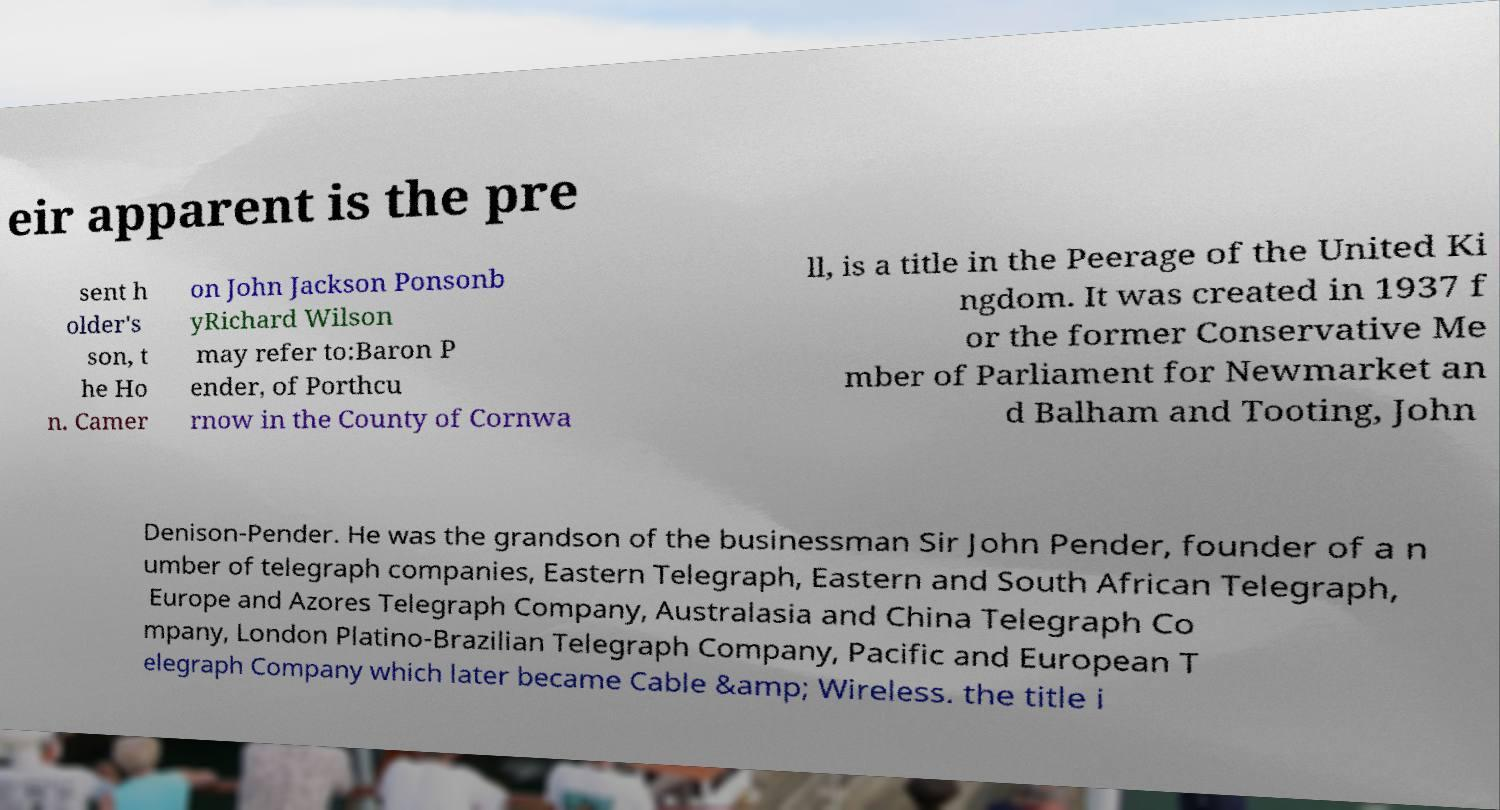What messages or text are displayed in this image? I need them in a readable, typed format. eir apparent is the pre sent h older's son, t he Ho n. Camer on John Jackson Ponsonb yRichard Wilson may refer to:Baron P ender, of Porthcu rnow in the County of Cornwa ll, is a title in the Peerage of the United Ki ngdom. It was created in 1937 f or the former Conservative Me mber of Parliament for Newmarket an d Balham and Tooting, John Denison-Pender. He was the grandson of the businessman Sir John Pender, founder of a n umber of telegraph companies, Eastern Telegraph, Eastern and South African Telegraph, Europe and Azores Telegraph Company, Australasia and China Telegraph Co mpany, London Platino-Brazilian Telegraph Company, Pacific and European T elegraph Company which later became Cable &amp; Wireless. the title i 